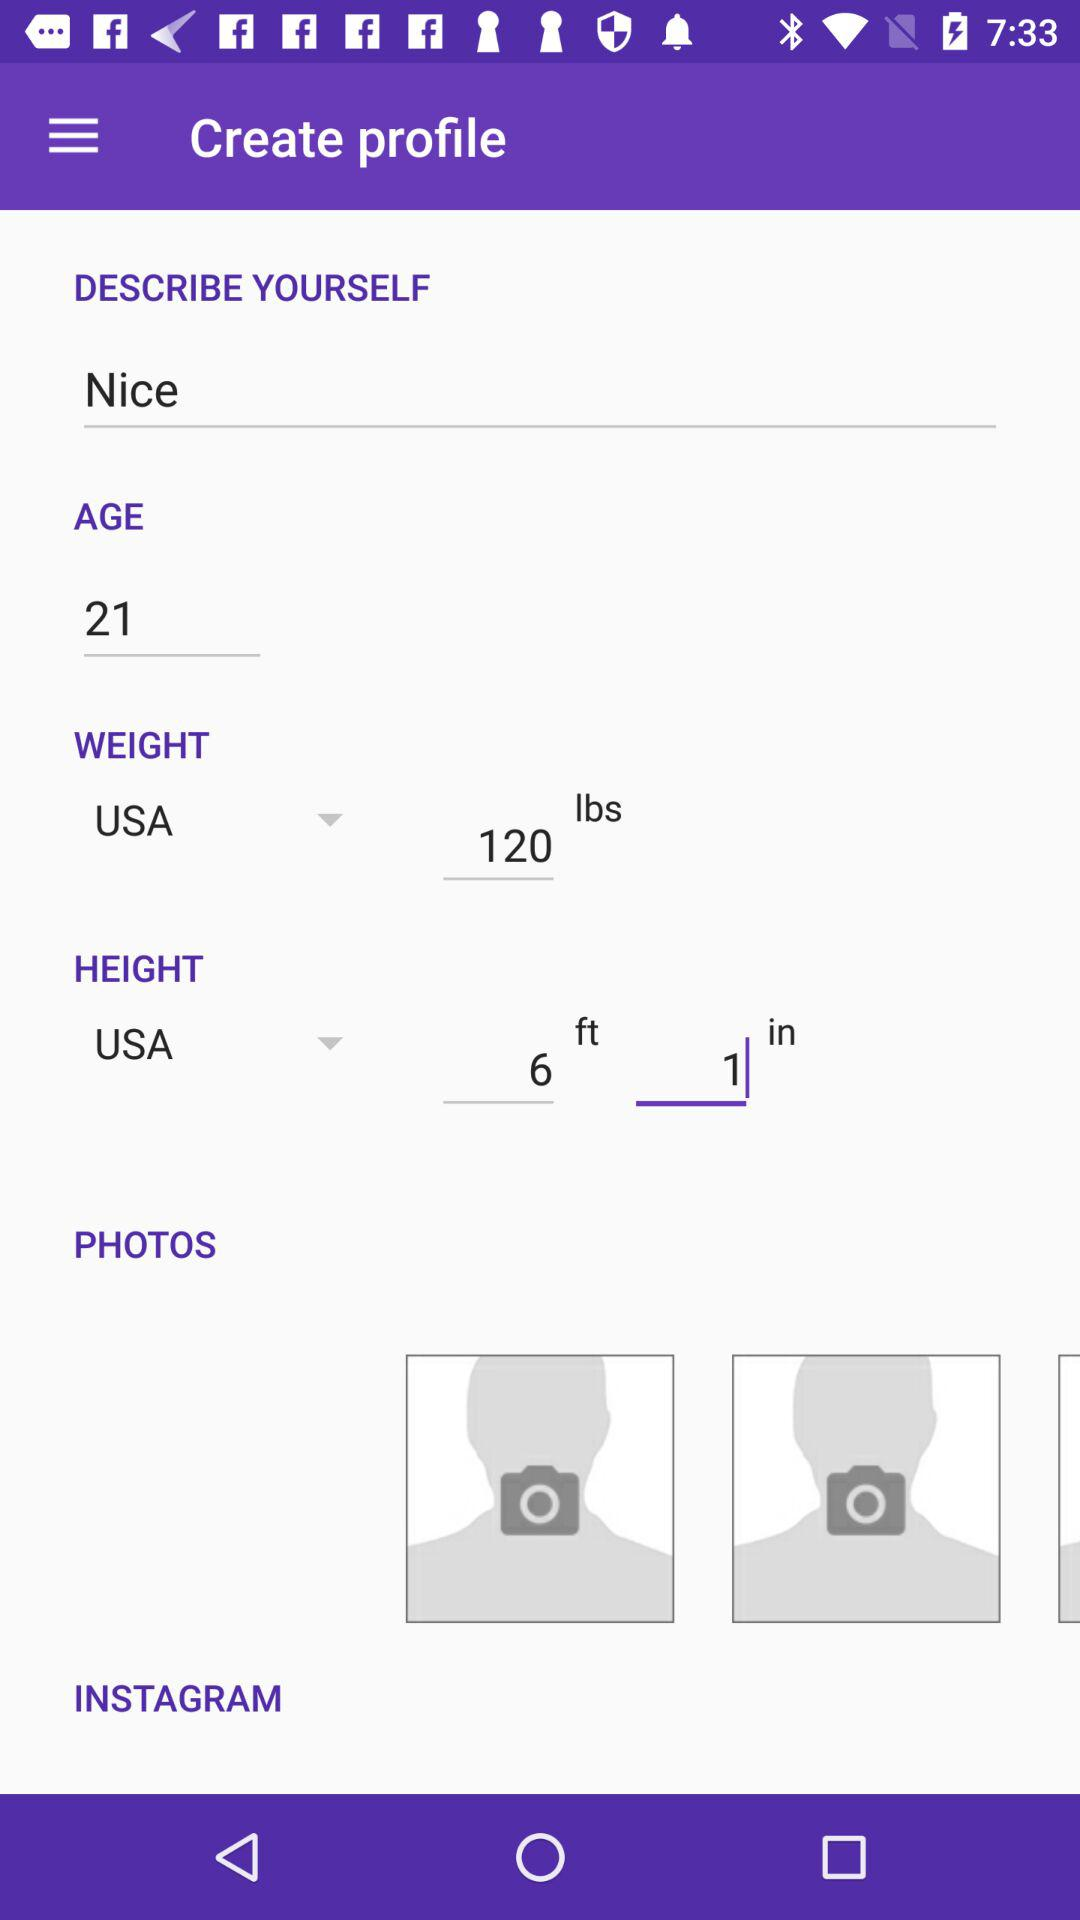How many more text inputs are there for the height than the weight?
Answer the question using a single word or phrase. 1 